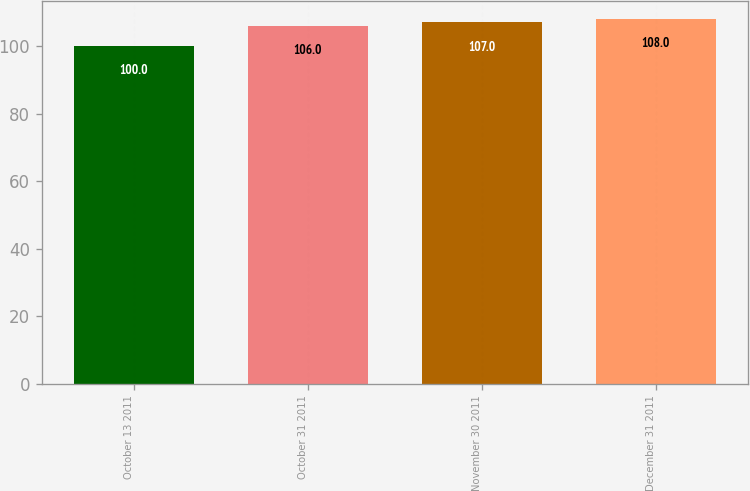<chart> <loc_0><loc_0><loc_500><loc_500><bar_chart><fcel>October 13 2011<fcel>October 31 2011<fcel>November 30 2011<fcel>December 31 2011<nl><fcel>100<fcel>106<fcel>107<fcel>108<nl></chart> 